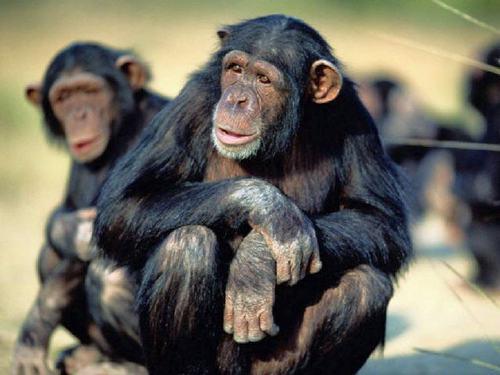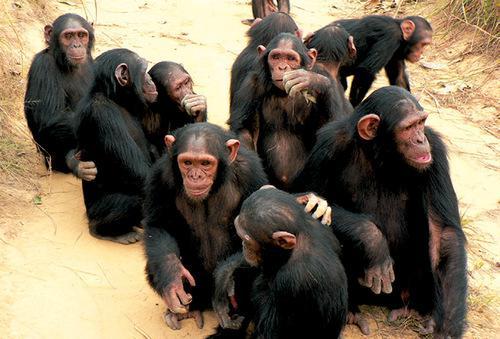The first image is the image on the left, the second image is the image on the right. Examine the images to the left and right. Is the description "There are more animals in the image on the right." accurate? Answer yes or no. Yes. The first image is the image on the left, the second image is the image on the right. Analyze the images presented: Is the assertion "At least one image shows a huddle of chimps in physical contact, and an image shows a forward-turned squatting chimp with one arm crossed over the other." valid? Answer yes or no. Yes. 